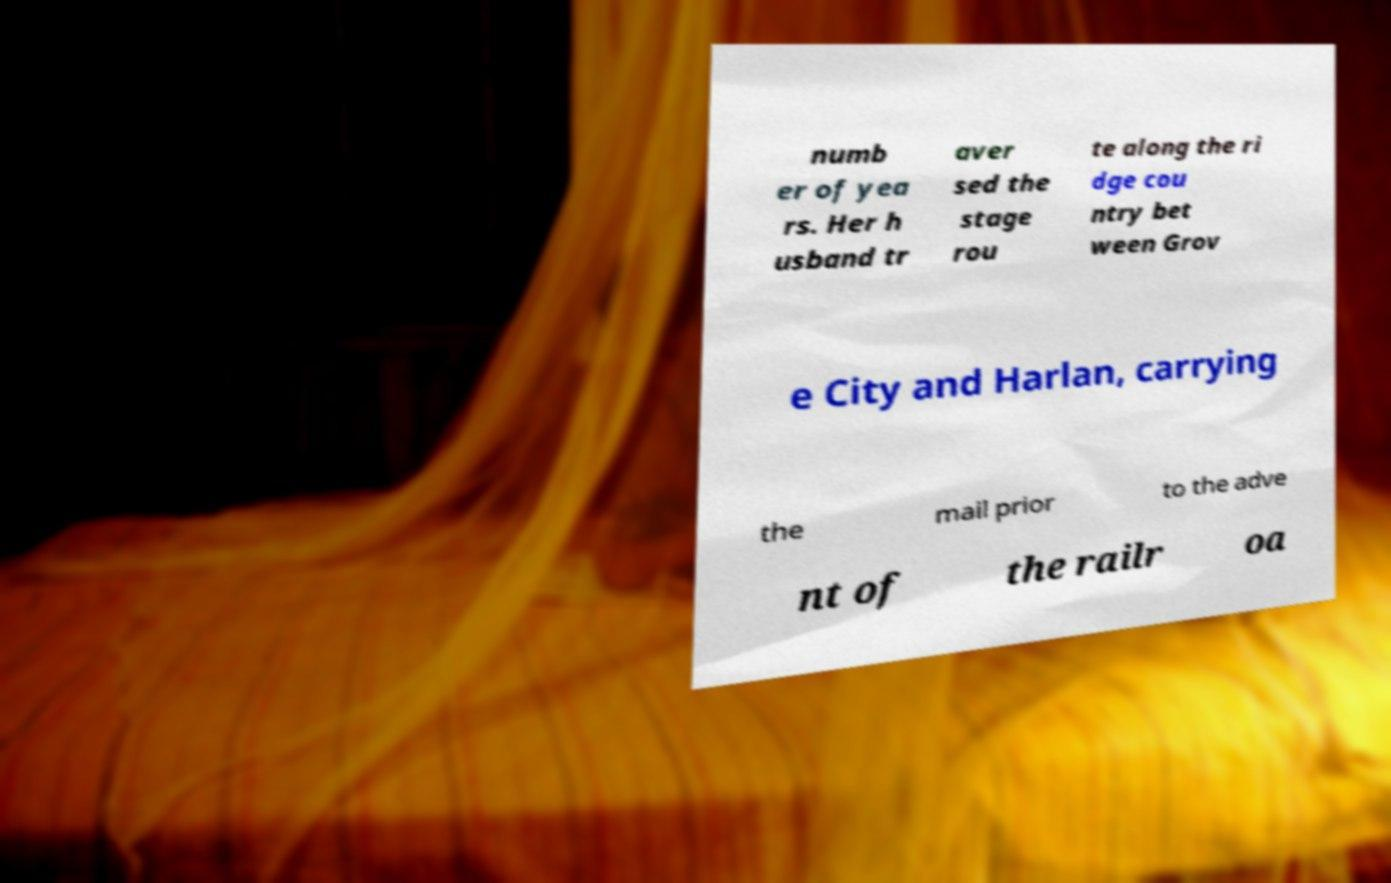Can you accurately transcribe the text from the provided image for me? numb er of yea rs. Her h usband tr aver sed the stage rou te along the ri dge cou ntry bet ween Grov e City and Harlan, carrying the mail prior to the adve nt of the railr oa 